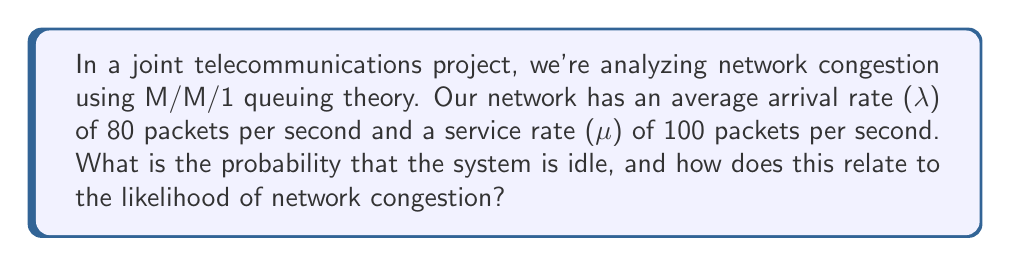Teach me how to tackle this problem. To solve this problem, we'll use M/M/1 queuing theory, which is applicable to our telecommunications network scenario. Let's break it down step-by-step:

1) First, we need to calculate the utilization factor (ρ), which is given by:

   $$\rho = \frac{\lambda}{\mu}$$

   Where:
   λ = arrival rate = 80 packets/second
   μ = service rate = 100 packets/second

   $$\rho = \frac{80}{100} = 0.8$$

2) In M/M/1 queuing theory, the probability that the system is idle (P₀) is given by:

   $$P_0 = 1 - \rho$$

3) Substituting our calculated ρ:

   $$P_0 = 1 - 0.8 = 0.2$$

4) This means there's a 20% chance that the system is idle at any given time.

5) The relationship to network congestion:
   - The probability of the system being busy is the complement of P₀:
     $$P(\text{busy}) = 1 - P_0 = 0.8 = 80\%$$
   - This 80% utilization indicates a high likelihood of network congestion.
   - Generally, utilization above 70-80% is considered to have a significant risk of congestion in telecommunications networks.

6) We can also calculate the average number of packets in the system (L) using Little's Law:

   $$L = \frac{\rho}{1-\rho} = \frac{0.8}{1-0.8} = 4$$

   This means, on average, there are 4 packets in the system, further indicating potential for congestion.
Answer: The probability that the system is idle is 0.2 or 20%. This implies an 80% utilization, indicating a high likelihood of network congestion. 